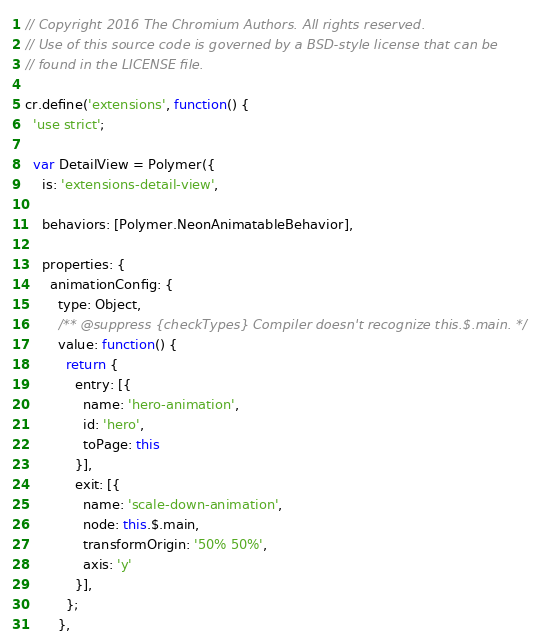Convert code to text. <code><loc_0><loc_0><loc_500><loc_500><_JavaScript_>// Copyright 2016 The Chromium Authors. All rights reserved.
// Use of this source code is governed by a BSD-style license that can be
// found in the LICENSE file.

cr.define('extensions', function() {
  'use strict';

  var DetailView = Polymer({
    is: 'extensions-detail-view',

    behaviors: [Polymer.NeonAnimatableBehavior],

    properties: {
      animationConfig: {
        type: Object,
        /** @suppress {checkTypes} Compiler doesn't recognize this.$.main. */
        value: function() {
          return {
            entry: [{
              name: 'hero-animation',
              id: 'hero',
              toPage: this
            }],
            exit: [{
              name: 'scale-down-animation',
              node: this.$.main,
              transformOrigin: '50% 50%',
              axis: 'y'
            }],
          };
        },</code> 